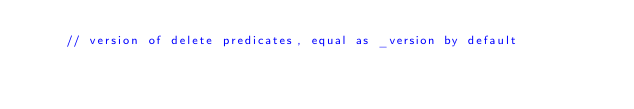<code> <loc_0><loc_0><loc_500><loc_500><_C_>    // version of delete predicates, equal as _version by default</code> 